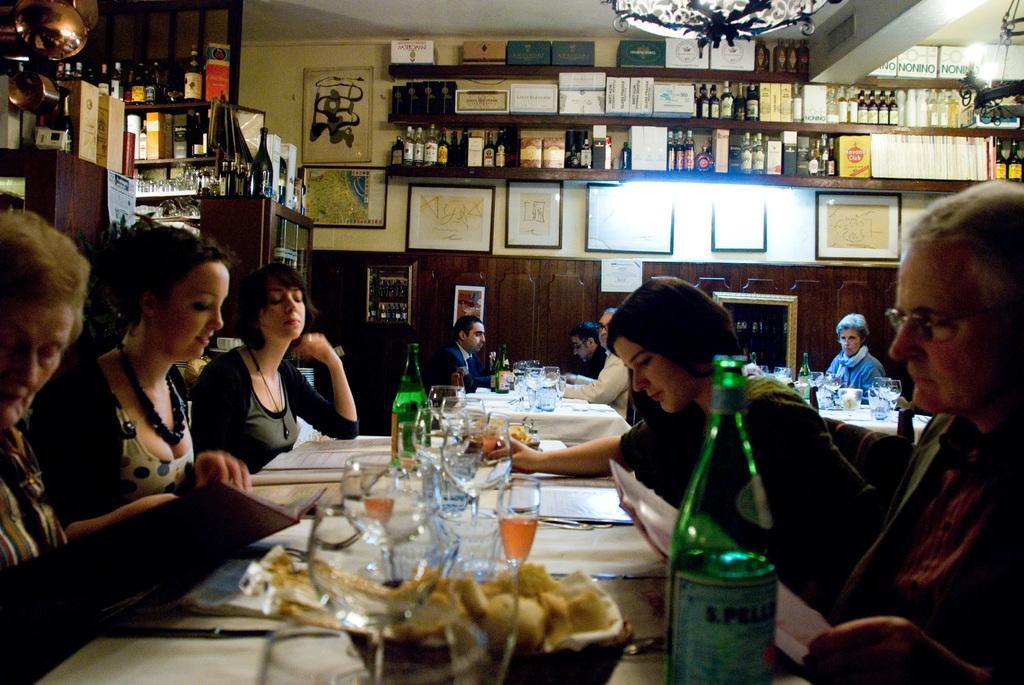Could you give a brief overview of what you see in this image? This image is clicked in a restaurant. There are many people in this image. In the front, there is a table on which glasses, bottles and plates are kept. To the left, there is a woman sitting. To the right, the man is wearing black suit and sitting. There are many chairs in this image. In the background, there are bottles in the rack and a wall on which some frames are fixed. 